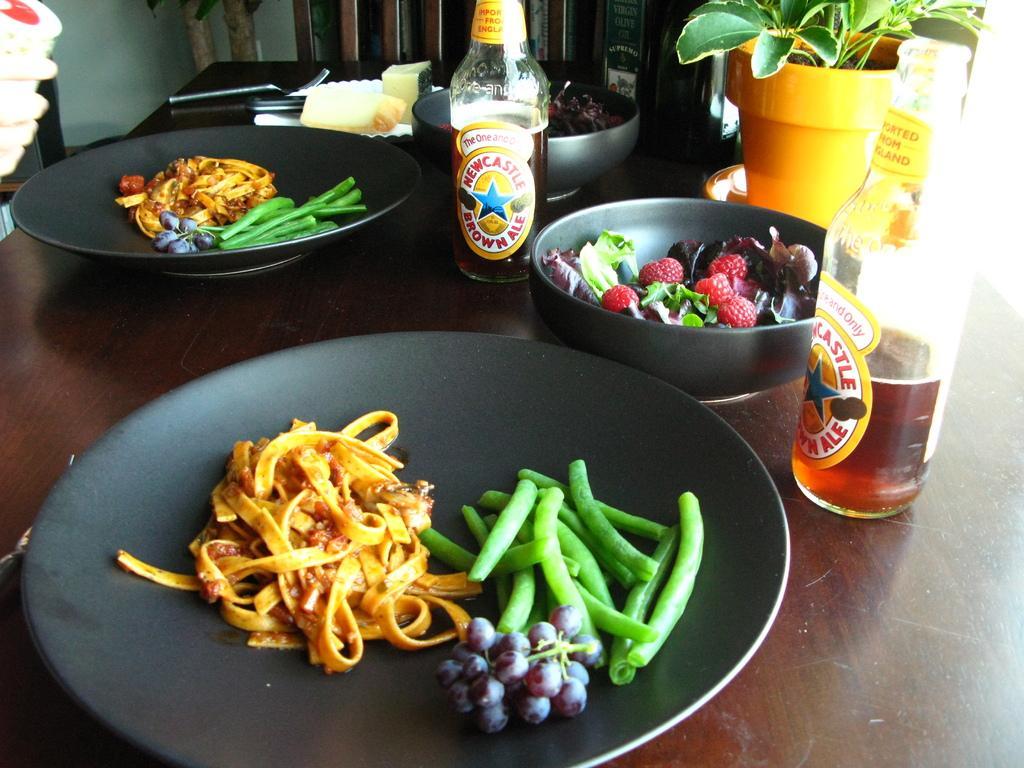Can you describe this image briefly? In this picture, we see two plates containing food item, beans and grapes, glass bottles, bowls containing fruits, flower pot and a spoon are placed on the brown table. In the background, we see a white wall. 